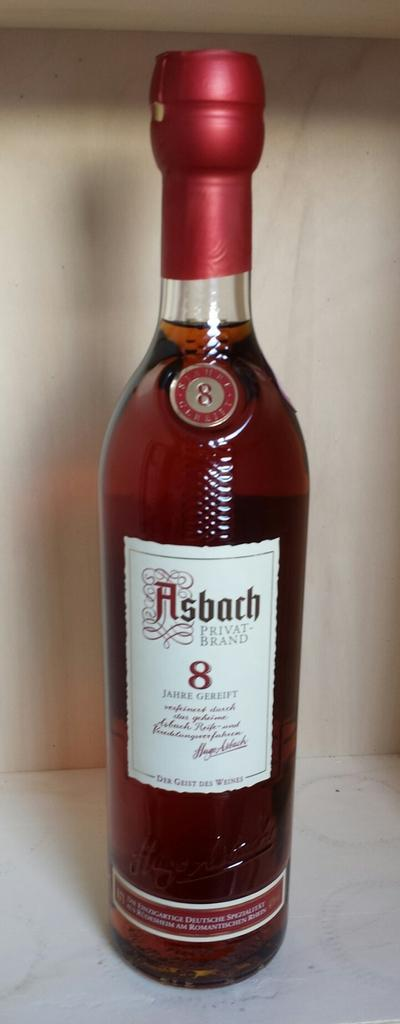Provide a one-sentence caption for the provided image. A maroon tinted, glass bottle of Asbach Privat-Brand liquor. 